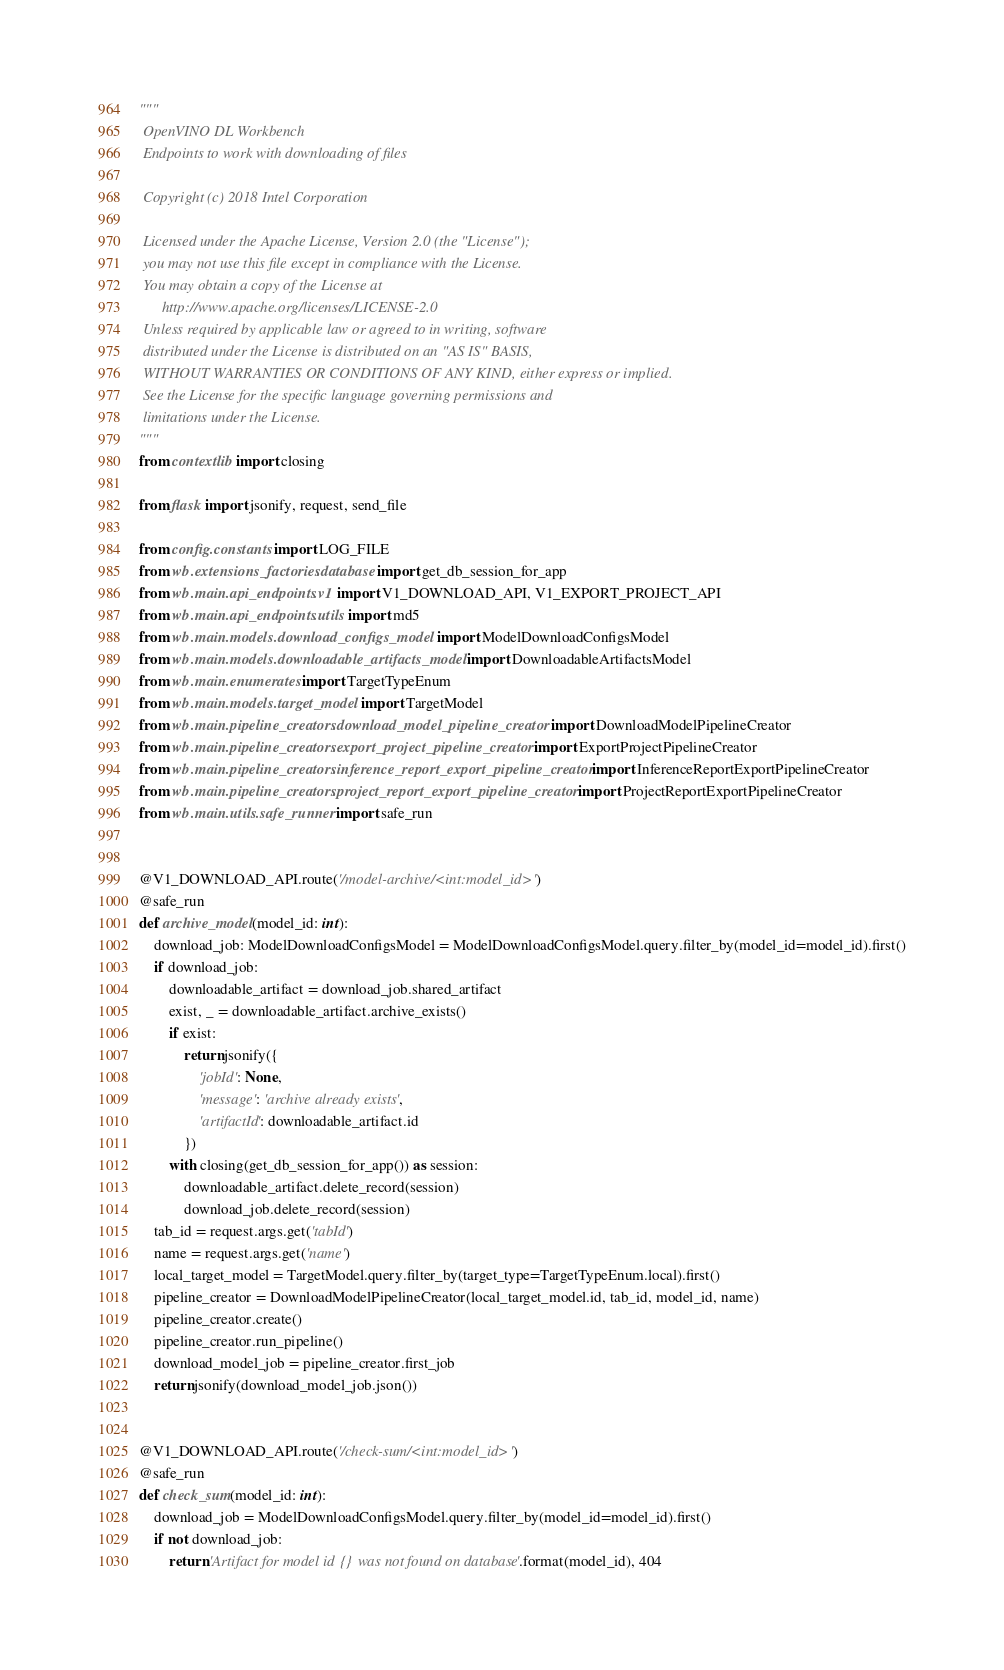Convert code to text. <code><loc_0><loc_0><loc_500><loc_500><_Python_>"""
 OpenVINO DL Workbench
 Endpoints to work with downloading of files

 Copyright (c) 2018 Intel Corporation

 Licensed under the Apache License, Version 2.0 (the "License");
 you may not use this file except in compliance with the License.
 You may obtain a copy of the License at
      http://www.apache.org/licenses/LICENSE-2.0
 Unless required by applicable law or agreed to in writing, software
 distributed under the License is distributed on an "AS IS" BASIS,
 WITHOUT WARRANTIES OR CONDITIONS OF ANY KIND, either express or implied.
 See the License for the specific language governing permissions and
 limitations under the License.
"""
from contextlib import closing

from flask import jsonify, request, send_file

from config.constants import LOG_FILE
from wb.extensions_factories.database import get_db_session_for_app
from wb.main.api_endpoints.v1 import V1_DOWNLOAD_API, V1_EXPORT_PROJECT_API
from wb.main.api_endpoints.utils import md5
from wb.main.models.download_configs_model import ModelDownloadConfigsModel
from wb.main.models.downloadable_artifacts_model import DownloadableArtifactsModel
from wb.main.enumerates import TargetTypeEnum
from wb.main.models.target_model import TargetModel
from wb.main.pipeline_creators.download_model_pipeline_creator import DownloadModelPipelineCreator
from wb.main.pipeline_creators.export_project_pipeline_creator import ExportProjectPipelineCreator
from wb.main.pipeline_creators.inference_report_export_pipeline_creator import InferenceReportExportPipelineCreator
from wb.main.pipeline_creators.project_report_export_pipeline_creator import ProjectReportExportPipelineCreator
from wb.main.utils.safe_runner import safe_run


@V1_DOWNLOAD_API.route('/model-archive/<int:model_id>')
@safe_run
def archive_model(model_id: int):
    download_job: ModelDownloadConfigsModel = ModelDownloadConfigsModel.query.filter_by(model_id=model_id).first()
    if download_job:
        downloadable_artifact = download_job.shared_artifact
        exist, _ = downloadable_artifact.archive_exists()
        if exist:
            return jsonify({
                'jobId': None,
                'message': 'archive already exists',
                'artifactId': downloadable_artifact.id
            })
        with closing(get_db_session_for_app()) as session:
            downloadable_artifact.delete_record(session)
            download_job.delete_record(session)
    tab_id = request.args.get('tabId')
    name = request.args.get('name')
    local_target_model = TargetModel.query.filter_by(target_type=TargetTypeEnum.local).first()
    pipeline_creator = DownloadModelPipelineCreator(local_target_model.id, tab_id, model_id, name)
    pipeline_creator.create()
    pipeline_creator.run_pipeline()
    download_model_job = pipeline_creator.first_job
    return jsonify(download_model_job.json())


@V1_DOWNLOAD_API.route('/check-sum/<int:model_id>')
@safe_run
def check_sum(model_id: int):
    download_job = ModelDownloadConfigsModel.query.filter_by(model_id=model_id).first()
    if not download_job:
        return 'Artifact for model id {} was not found on database'.format(model_id), 404</code> 